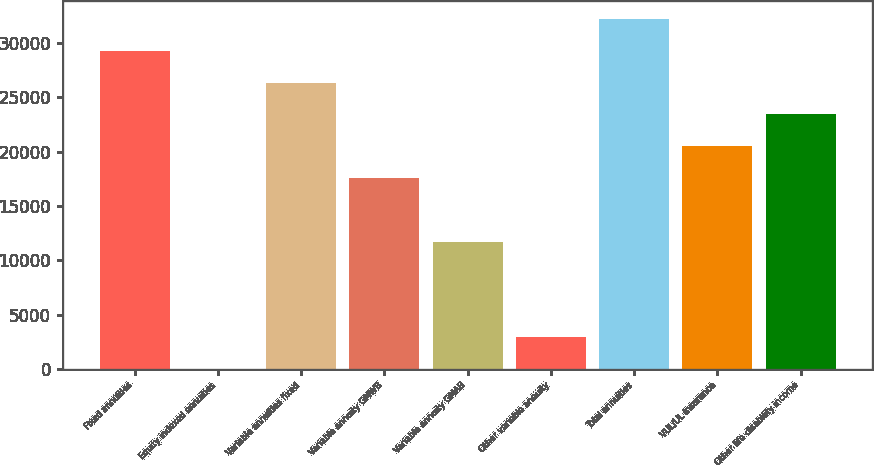Convert chart to OTSL. <chart><loc_0><loc_0><loc_500><loc_500><bar_chart><fcel>Fixed annuities<fcel>Equity indexed annuities<fcel>Variable annuities fixed<fcel>Variable annuity GMWB<fcel>Variable annuity GMAB<fcel>Other variable annuity<fcel>Total annuities<fcel>VUL/UL insurance<fcel>Other life disability income<nl><fcel>29293<fcel>16<fcel>26365.3<fcel>17582.2<fcel>11726.8<fcel>2943.7<fcel>32220.7<fcel>20509.9<fcel>23437.6<nl></chart> 